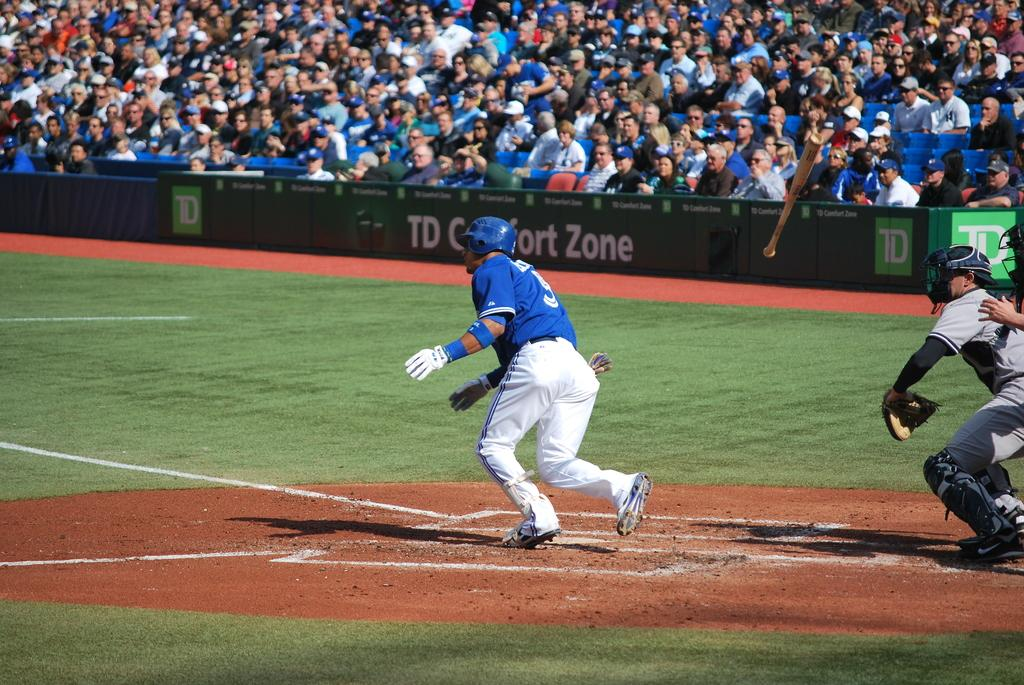<image>
Create a compact narrative representing the image presented. A baseball game and a TD comfort zone advertisement in the background. 